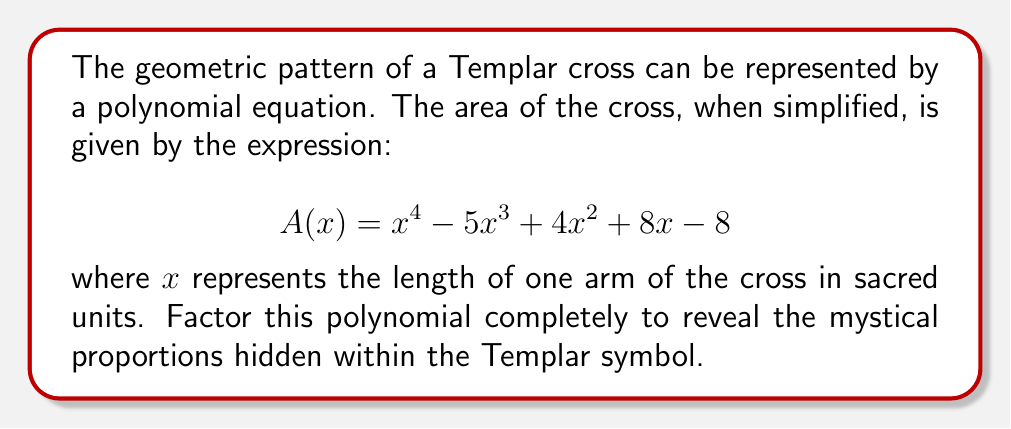Could you help me with this problem? To factor this polynomial, we'll follow these steps:

1) First, let's check if there are any rational roots using the rational root theorem. The possible rational roots are the factors of the constant term: ±1, ±2, ±4, ±8.

2) Testing these values, we find that $x = 1$ and $x = 2$ are roots of the polynomial.

3) We can factor out $(x-1)$ and $(x-2)$:

   $A(x) = (x-1)(x-2)(x^2 + ax + b)$

4) Expanding this and comparing coefficients with the original polynomial, we can determine $a$ and $b$:

   $x^4 - 5x^3 + 4x^2 + 8x - 8 = (x-1)(x-2)(x^2 + ax + b)$
   $= x^4 + (a-3)x^3 + (b-2a+2)x^2 + (2a-b)x - 2b$

5) Comparing coefficients:
   $a-3 = -5$, so $a = -2$
   $-2b = -8$, so $b = 4$

6) Therefore, the quadratic factor is $x^2 - 2x + 4$

7) This quadratic doesn't factor further over the real numbers, as its discriminant is negative:
   $b^2 - 4ac = (-2)^2 - 4(1)(4) = 4 - 16 = -12$

Thus, the complete factorization is:

$$ A(x) = (x-1)(x-2)(x^2 - 2x + 4) $$

This factorization reveals the mystical proportions within the Templar cross: two linear factors representing the visible dimensions (1 and 2), and a quadratic factor representing the hidden, complex relationship between the physical and spiritual realms.
Answer: $$ A(x) = (x-1)(x-2)(x^2 - 2x + 4) $$ 